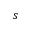<formula> <loc_0><loc_0><loc_500><loc_500>s</formula> 